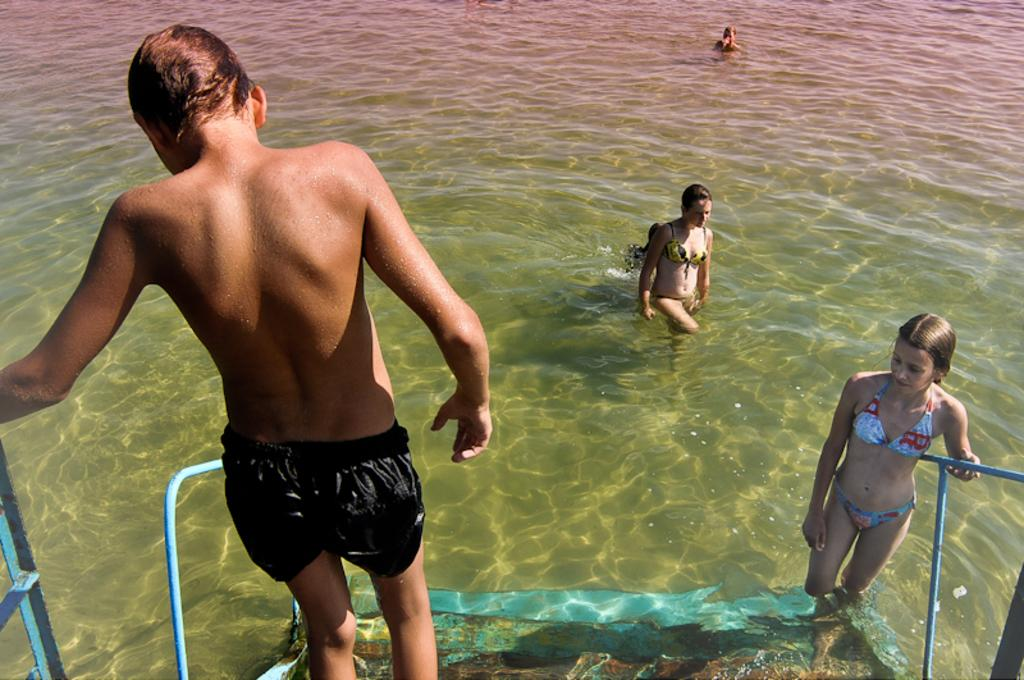What are the persons in the image doing? The persons in the image are swimming in the water. What type of clothing are some of the persons wearing? Some of the persons are wearing shorts and bikinis. Can you describe the foreground of the image? At the foreground of the image, there are two persons walking on the stairs. What type of flower is being selected by the maid in the image? There is no maid or flower present in the image. 